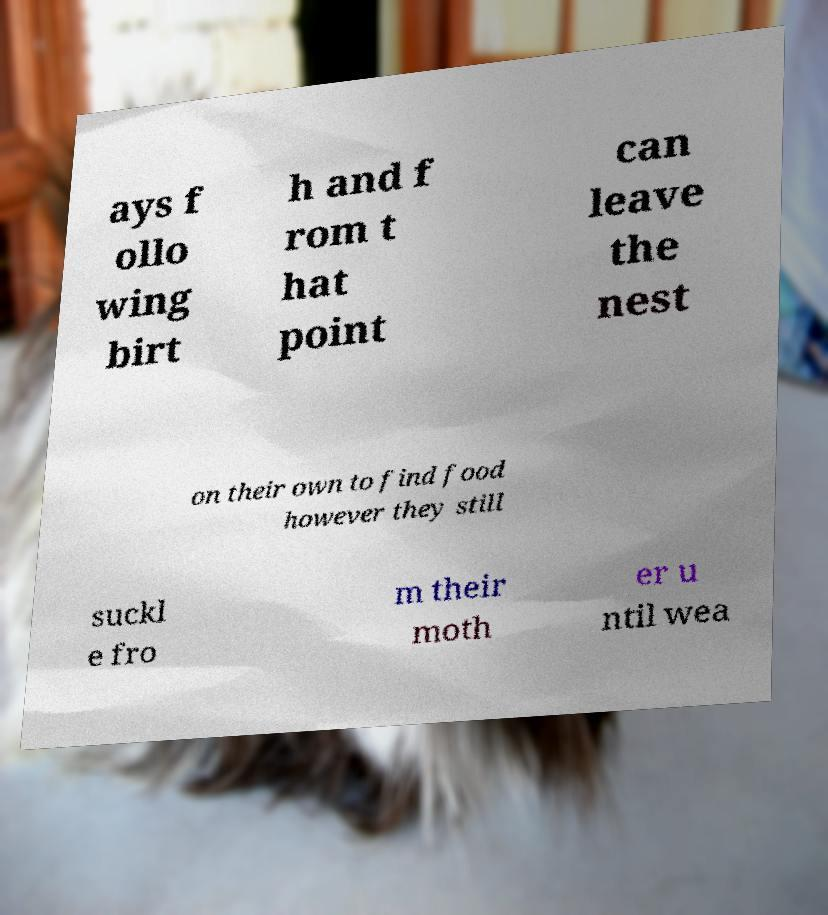Please identify and transcribe the text found in this image. ays f ollo wing birt h and f rom t hat point can leave the nest on their own to find food however they still suckl e fro m their moth er u ntil wea 